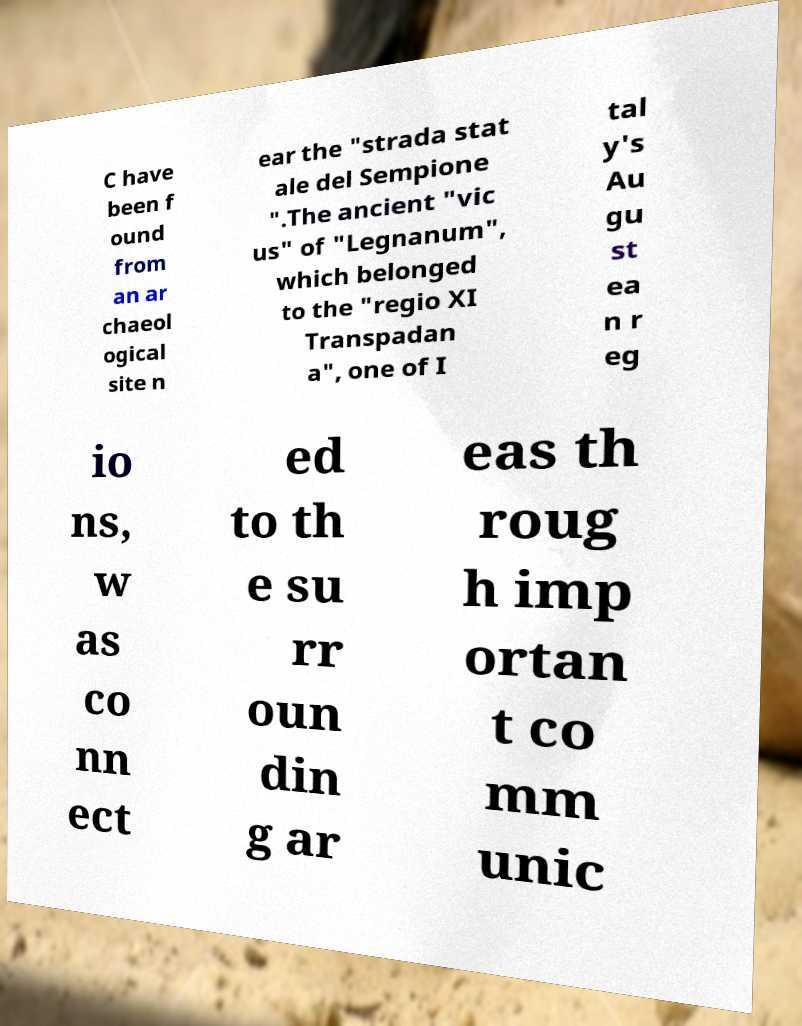I need the written content from this picture converted into text. Can you do that? C have been f ound from an ar chaeol ogical site n ear the "strada stat ale del Sempione ".The ancient "vic us" of "Legnanum", which belonged to the "regio XI Transpadan a", one of I tal y's Au gu st ea n r eg io ns, w as co nn ect ed to th e su rr oun din g ar eas th roug h imp ortan t co mm unic 